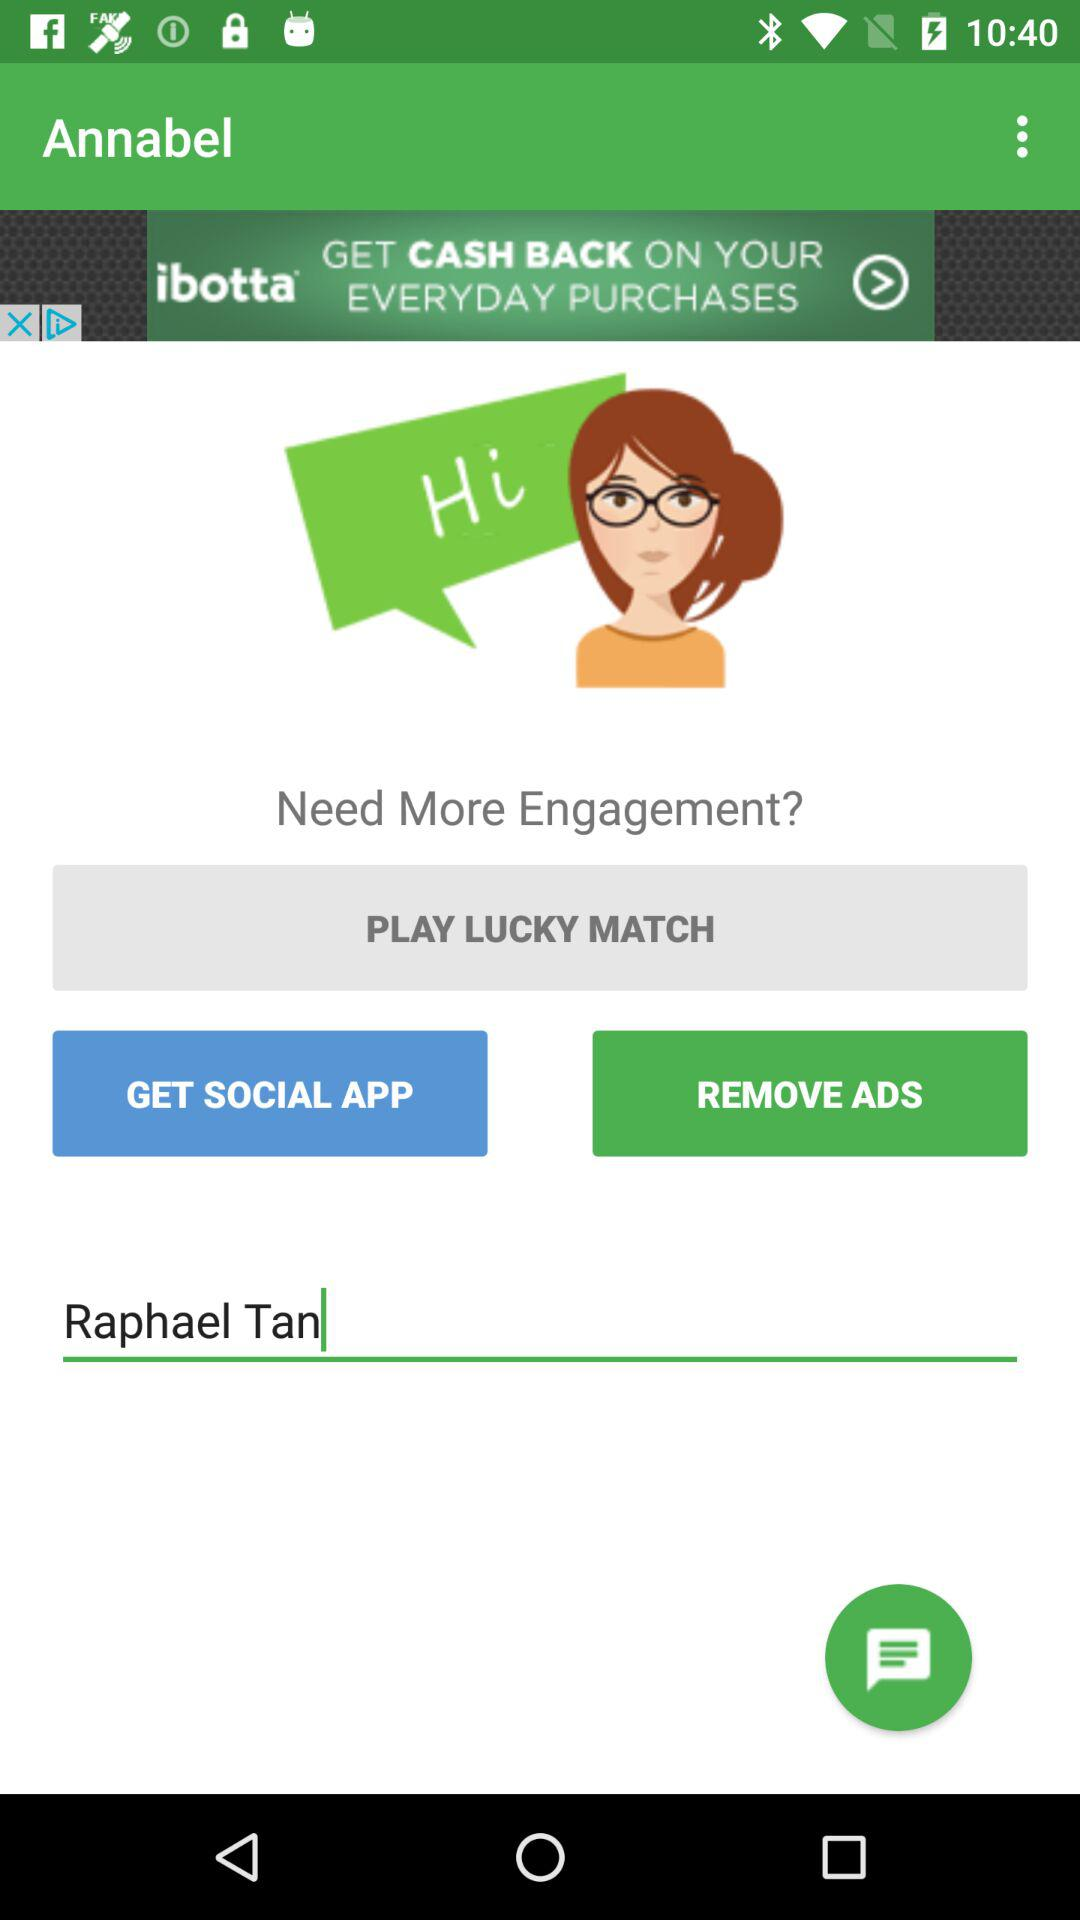What's the user name? The user name is "Raphael Tan". 